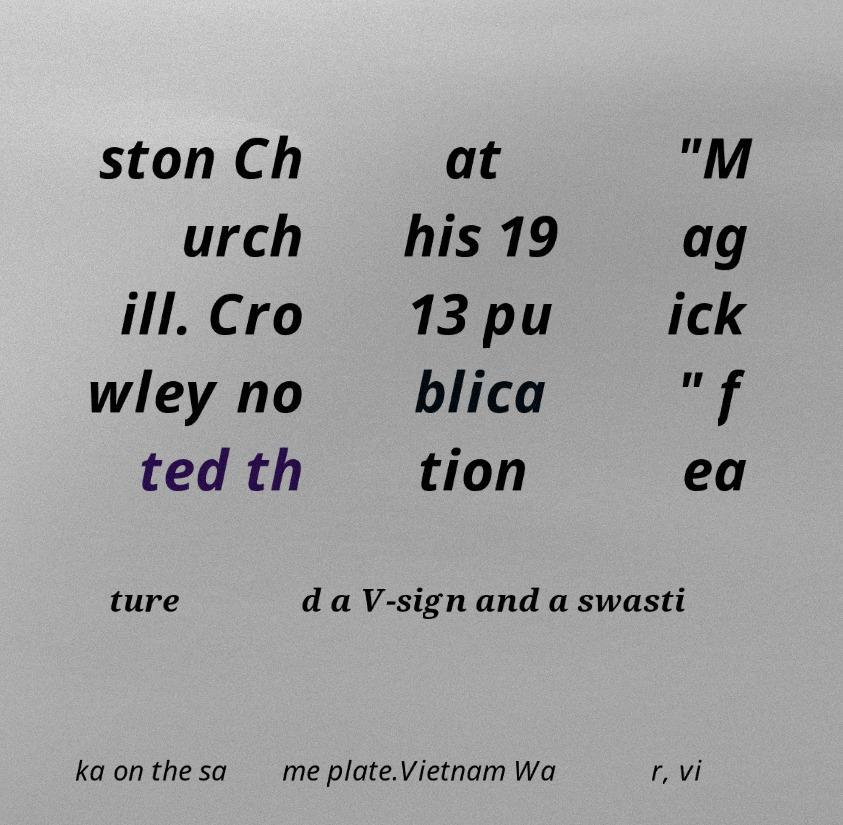Could you assist in decoding the text presented in this image and type it out clearly? ston Ch urch ill. Cro wley no ted th at his 19 13 pu blica tion "M ag ick " f ea ture d a V-sign and a swasti ka on the sa me plate.Vietnam Wa r, vi 